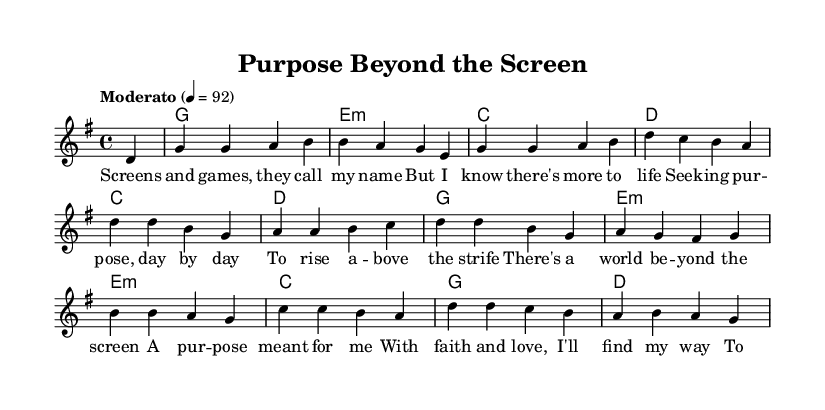What is the key signature of this music? The key signature is G major, which has one sharp (F#).
Answer: G major What is the time signature of this music? The time signature is 4/4, indicating that there are four beats in each measure.
Answer: 4/4 What is the tempo marking for this piece? The piece has a tempo marking of "Moderato" with a metronome mark of 92.
Answer: Moderato 92 How many measures are in the song? By counting the measures indicated in the music, there are 12 measures in total.
Answer: 12 What is the first lyric line of the song? The first lyric line is "Screens and games, they call my name." This is the opening of the lyrics which introduces the theme.
Answer: Screens and games, they call my name What chords are used in the first two measures? The first two measures contain the chords G and E minor, which are foundational for the progression.
Answer: G, E minor What theme does the song express according to the lyrics? The lyrics express a search for purpose beyond entertainment and a desire to find a greater meaning in life.
Answer: Finding purpose 